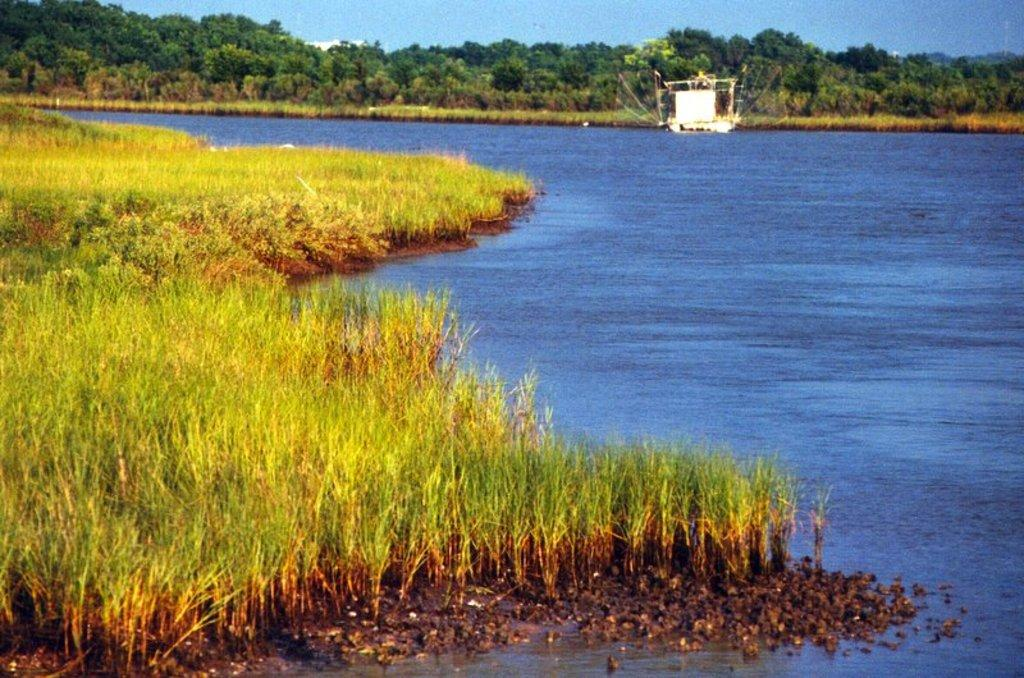What type of vegetation can be seen in the image? There is grass in the image. What else is present in the image besides grass? There is water in the image. What can be seen in the background of the image? There are trees and the sky visible in the background of the image. Where is the nest of the bird in the image? There is no nest or bird present in the image. What effect does the grass have on the water in the image? The grass does not have any effect on the water in the image, as they are separate elements in the scene. 